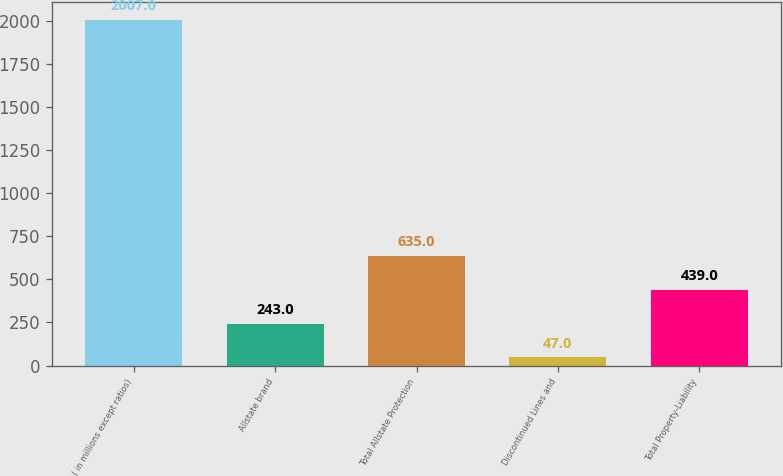<chart> <loc_0><loc_0><loc_500><loc_500><bar_chart><fcel>( in millions except ratios)<fcel>Allstate brand<fcel>Total Allstate Protection<fcel>Discontinued Lines and<fcel>Total Property-Liability<nl><fcel>2007<fcel>243<fcel>635<fcel>47<fcel>439<nl></chart> 